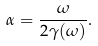<formula> <loc_0><loc_0><loc_500><loc_500>\alpha = \frac { \omega } { 2 \gamma ( \omega ) } .</formula> 